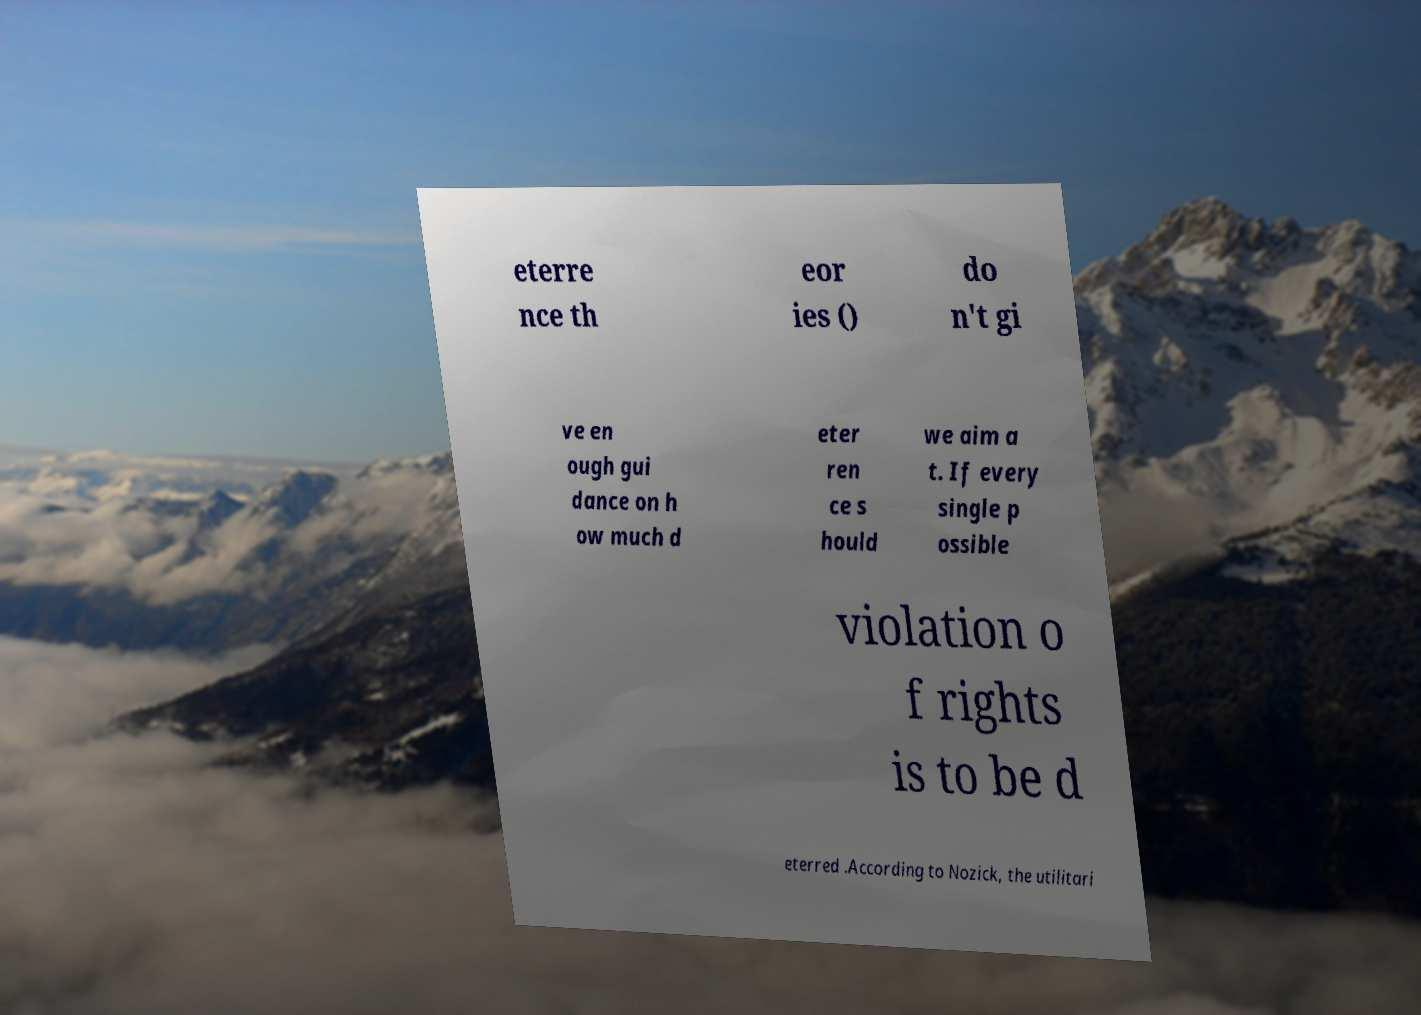I need the written content from this picture converted into text. Can you do that? eterre nce th eor ies () do n't gi ve en ough gui dance on h ow much d eter ren ce s hould we aim a t. If every single p ossible violation o f rights is to be d eterred .According to Nozick, the utilitari 